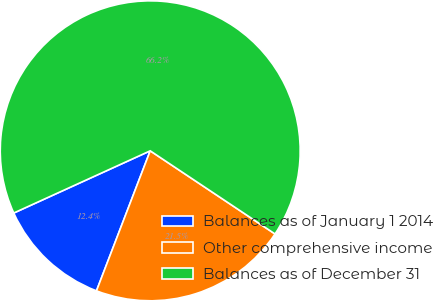Convert chart to OTSL. <chart><loc_0><loc_0><loc_500><loc_500><pie_chart><fcel>Balances as of January 1 2014<fcel>Other comprehensive income<fcel>Balances as of December 31<nl><fcel>12.36%<fcel>21.48%<fcel>66.16%<nl></chart> 